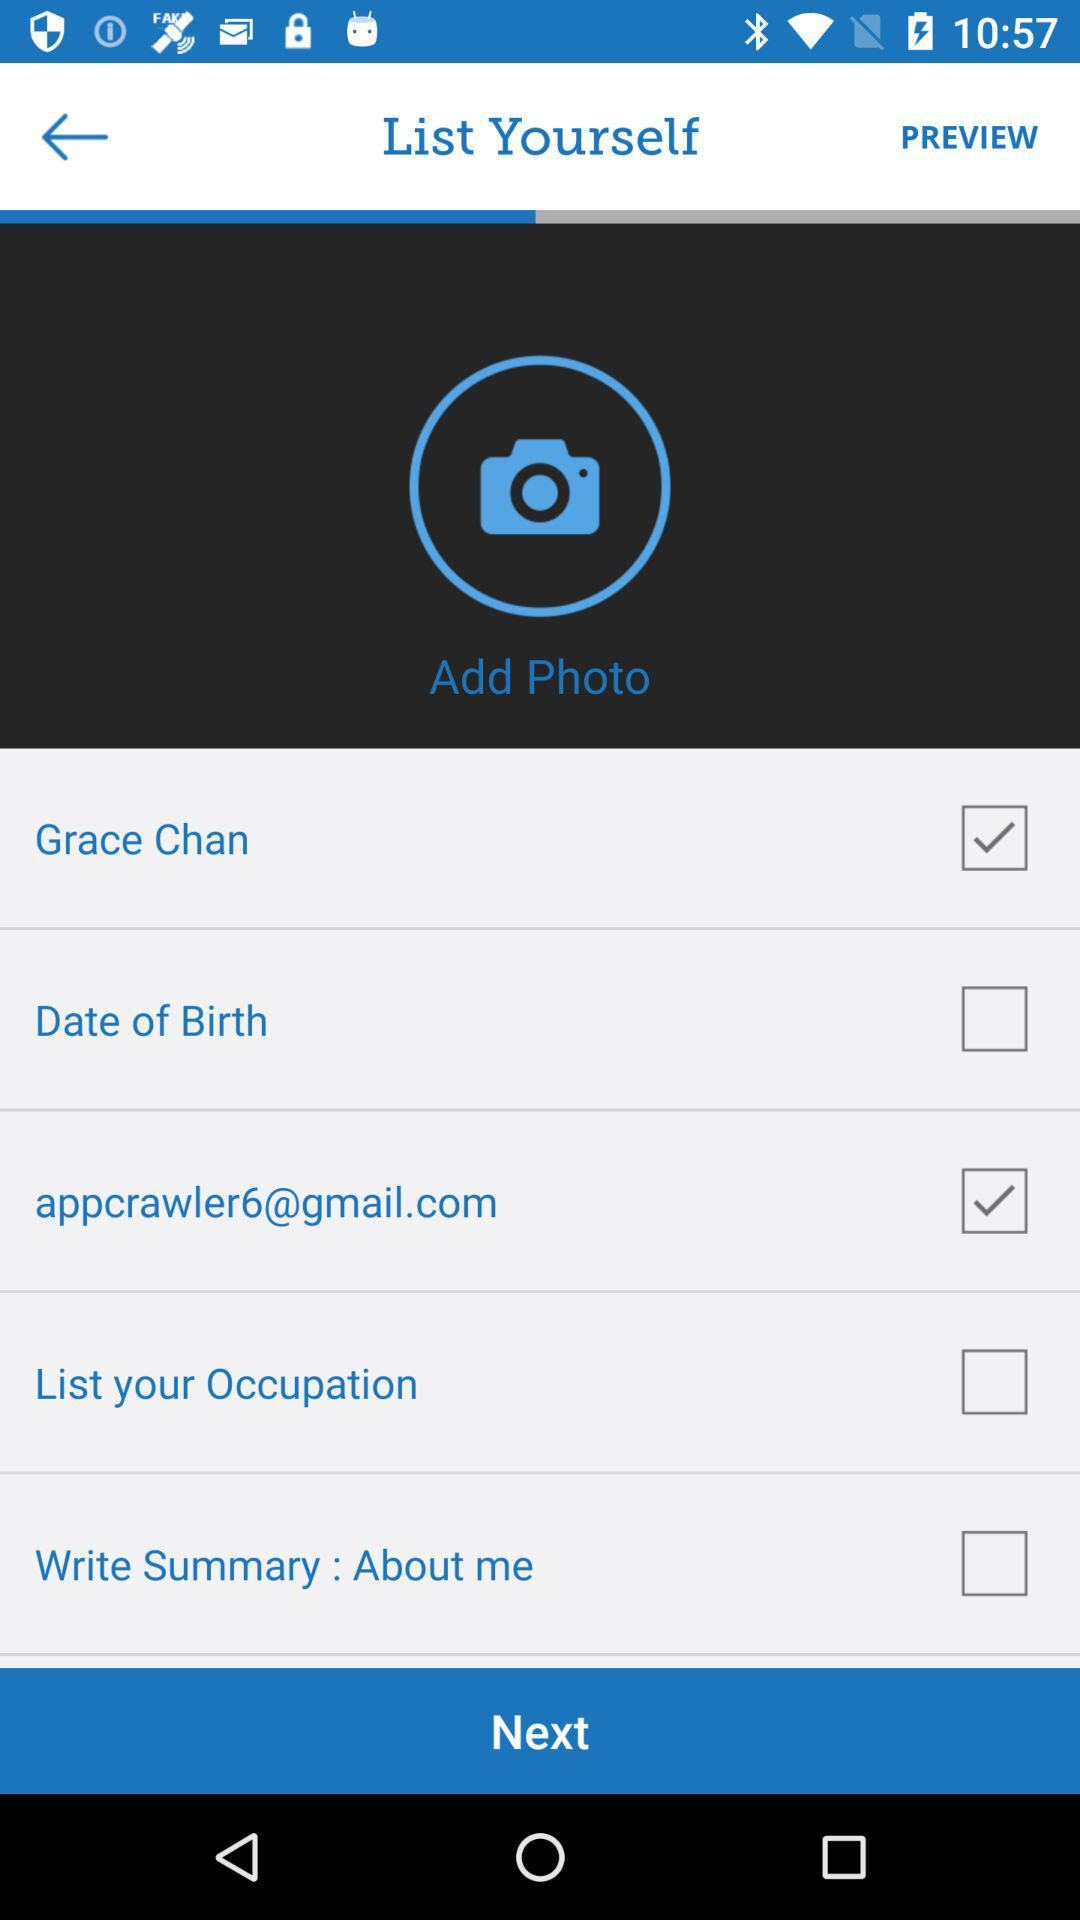Which is the selected checkbox? The selected checkboxes are "Grace Chan" and "appcrawler6@gmail.com". 